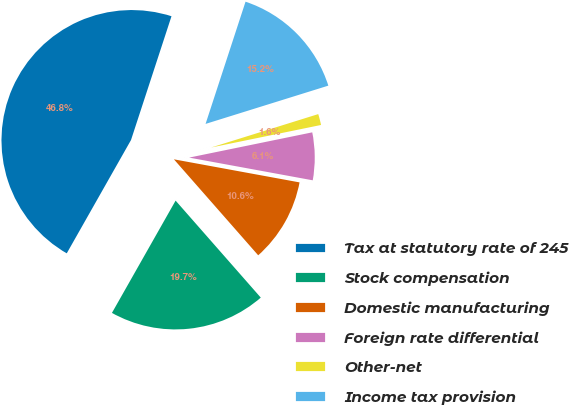<chart> <loc_0><loc_0><loc_500><loc_500><pie_chart><fcel>Tax at statutory rate of 245<fcel>Stock compensation<fcel>Domestic manufacturing<fcel>Foreign rate differential<fcel>Other-net<fcel>Income tax provision<nl><fcel>46.82%<fcel>19.68%<fcel>10.64%<fcel>6.11%<fcel>1.59%<fcel>15.16%<nl></chart> 